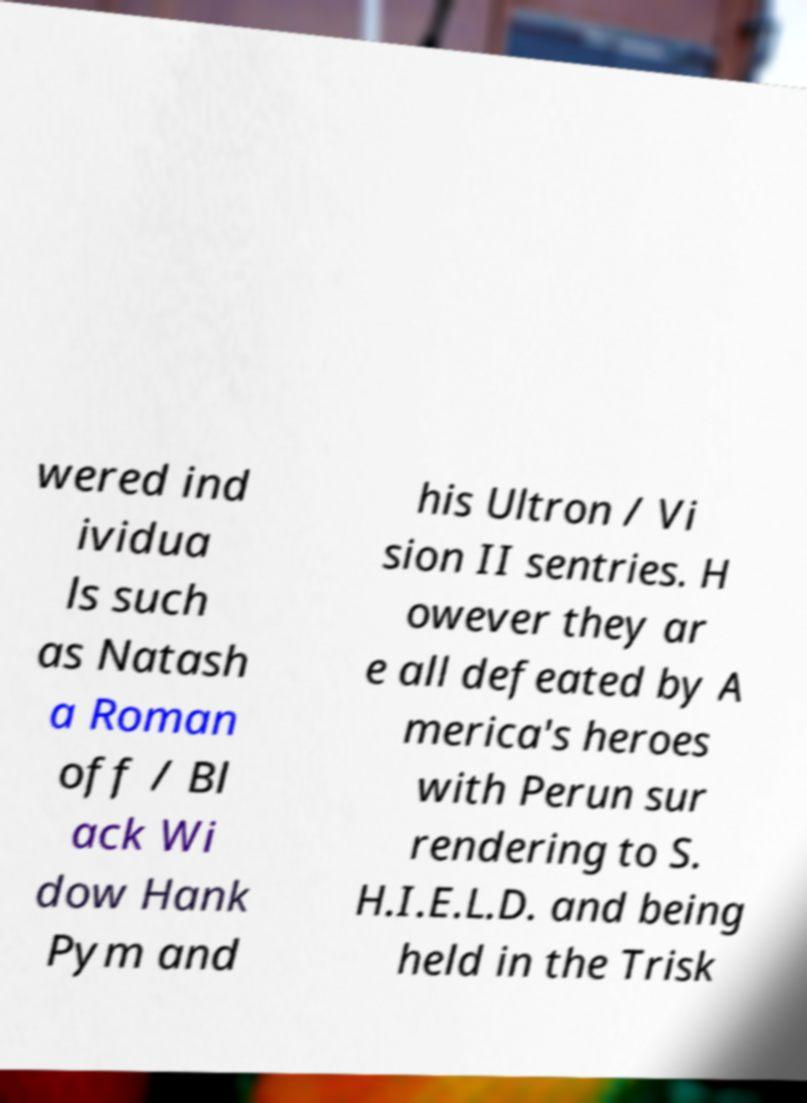There's text embedded in this image that I need extracted. Can you transcribe it verbatim? wered ind ividua ls such as Natash a Roman off / Bl ack Wi dow Hank Pym and his Ultron / Vi sion II sentries. H owever they ar e all defeated by A merica's heroes with Perun sur rendering to S. H.I.E.L.D. and being held in the Trisk 